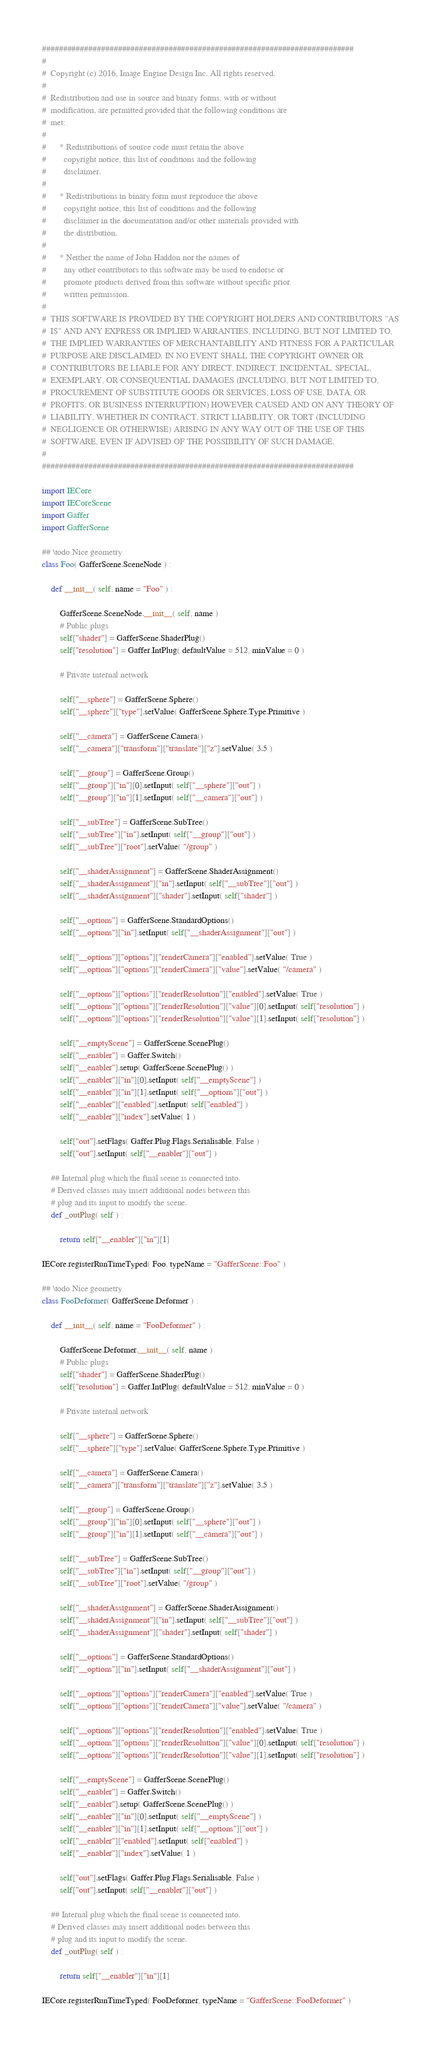<code> <loc_0><loc_0><loc_500><loc_500><_Python_>##########################################################################
#
#  Copyright (c) 2016, Image Engine Design Inc. All rights reserved.
#
#  Redistribution and use in source and binary forms, with or without
#  modification, are permitted provided that the following conditions are
#  met:
#
#      * Redistributions of source code must retain the above
#        copyright notice, this list of conditions and the following
#        disclaimer.
#
#      * Redistributions in binary form must reproduce the above
#        copyright notice, this list of conditions and the following
#        disclaimer in the documentation and/or other materials provided with
#        the distribution.
#
#      * Neither the name of John Haddon nor the names of
#        any other contributors to this software may be used to endorse or
#        promote products derived from this software without specific prior
#        written permission.
#
#  THIS SOFTWARE IS PROVIDED BY THE COPYRIGHT HOLDERS AND CONTRIBUTORS "AS
#  IS" AND ANY EXPRESS OR IMPLIED WARRANTIES, INCLUDING, BUT NOT LIMITED TO,
#  THE IMPLIED WARRANTIES OF MERCHANTABILITY AND FITNESS FOR A PARTICULAR
#  PURPOSE ARE DISCLAIMED. IN NO EVENT SHALL THE COPYRIGHT OWNER OR
#  CONTRIBUTORS BE LIABLE FOR ANY DIRECT, INDIRECT, INCIDENTAL, SPECIAL,
#  EXEMPLARY, OR CONSEQUENTIAL DAMAGES (INCLUDING, BUT NOT LIMITED TO,
#  PROCUREMENT OF SUBSTITUTE GOODS OR SERVICES; LOSS OF USE, DATA, OR
#  PROFITS; OR BUSINESS INTERRUPTION) HOWEVER CAUSED AND ON ANY THEORY OF
#  LIABILITY, WHETHER IN CONTRACT, STRICT LIABILITY, OR TORT (INCLUDING
#  NEGLIGENCE OR OTHERWISE) ARISING IN ANY WAY OUT OF THE USE OF THIS
#  SOFTWARE, EVEN IF ADVISED OF THE POSSIBILITY OF SUCH DAMAGE.
#
##########################################################################

import IECore
import IECoreScene
import Gaffer
import GafferScene

## \todo Nice geometry
class Foo( GafferScene.SceneNode ) :

	def __init__( self, name = "Foo" ) :

		GafferScene.SceneNode.__init__( self, name )
		# Public plugs
		self["shader"] = GafferScene.ShaderPlug()
		self["resolution"] = Gaffer.IntPlug( defaultValue = 512, minValue = 0 )

		# Private internal network

		self["__sphere"] = GafferScene.Sphere()
		self["__sphere"]["type"].setValue( GafferScene.Sphere.Type.Primitive )

		self["__camera"] = GafferScene.Camera()
		self["__camera"]["transform"]["translate"]["z"].setValue( 3.5 )

		self["__group"] = GafferScene.Group()
		self["__group"]["in"][0].setInput( self["__sphere"]["out"] )
		self["__group"]["in"][1].setInput( self["__camera"]["out"] )

		self["__subTree"] = GafferScene.SubTree()
		self["__subTree"]["in"].setInput( self["__group"]["out"] )
		self["__subTree"]["root"].setValue( "/group" )

		self["__shaderAssignment"] = GafferScene.ShaderAssignment()
		self["__shaderAssignment"]["in"].setInput( self["__subTree"]["out"] )
		self["__shaderAssignment"]["shader"].setInput( self["shader"] )

		self["__options"] = GafferScene.StandardOptions()
		self["__options"]["in"].setInput( self["__shaderAssignment"]["out"] )

		self["__options"]["options"]["renderCamera"]["enabled"].setValue( True )
		self["__options"]["options"]["renderCamera"]["value"].setValue( "/camera" )

		self["__options"]["options"]["renderResolution"]["enabled"].setValue( True )
		self["__options"]["options"]["renderResolution"]["value"][0].setInput( self["resolution"] )
		self["__options"]["options"]["renderResolution"]["value"][1].setInput( self["resolution"] )

		self["__emptyScene"] = GafferScene.ScenePlug()
		self["__enabler"] = Gaffer.Switch()
		self["__enabler"].setup( GafferScene.ScenePlug() )
		self["__enabler"]["in"][0].setInput( self["__emptyScene"] )
		self["__enabler"]["in"][1].setInput( self["__options"]["out"] )
		self["__enabler"]["enabled"].setInput( self["enabled"] )
		self["__enabler"]["index"].setValue( 1 )

		self["out"].setFlags( Gaffer.Plug.Flags.Serialisable, False )
		self["out"].setInput( self["__enabler"]["out"] )

	## Internal plug which the final scene is connected into.
	# Derived classes may insert additional nodes between this
	# plug and its input to modify the scene.
	def _outPlug( self ) :

		return self["__enabler"]["in"][1]

IECore.registerRunTimeTyped( Foo, typeName = "GafferScene::Foo" )

## \todo Nice geometry
class FooDeformer( GafferScene.Deformer ) :

	def __init__( self, name = "FooDeformer" ) :

		GafferScene.Deformer.__init__( self, name )
		# Public plugs
		self["shader"] = GafferScene.ShaderPlug()
		self["resolution"] = Gaffer.IntPlug( defaultValue = 512, minValue = 0 )

		# Private internal network

		self["__sphere"] = GafferScene.Sphere()
		self["__sphere"]["type"].setValue( GafferScene.Sphere.Type.Primitive )

		self["__camera"] = GafferScene.Camera()
		self["__camera"]["transform"]["translate"]["z"].setValue( 3.5 )

		self["__group"] = GafferScene.Group()
		self["__group"]["in"][0].setInput( self["__sphere"]["out"] )
		self["__group"]["in"][1].setInput( self["__camera"]["out"] )

		self["__subTree"] = GafferScene.SubTree()
		self["__subTree"]["in"].setInput( self["__group"]["out"] )
		self["__subTree"]["root"].setValue( "/group" )

		self["__shaderAssignment"] = GafferScene.ShaderAssignment()
		self["__shaderAssignment"]["in"].setInput( self["__subTree"]["out"] )
		self["__shaderAssignment"]["shader"].setInput( self["shader"] )

		self["__options"] = GafferScene.StandardOptions()
		self["__options"]["in"].setInput( self["__shaderAssignment"]["out"] )

		self["__options"]["options"]["renderCamera"]["enabled"].setValue( True )
		self["__options"]["options"]["renderCamera"]["value"].setValue( "/camera" )

		self["__options"]["options"]["renderResolution"]["enabled"].setValue( True )
		self["__options"]["options"]["renderResolution"]["value"][0].setInput( self["resolution"] )
		self["__options"]["options"]["renderResolution"]["value"][1].setInput( self["resolution"] )

		self["__emptyScene"] = GafferScene.ScenePlug()
		self["__enabler"] = Gaffer.Switch()
		self["__enabler"].setup( GafferScene.ScenePlug() )
		self["__enabler"]["in"][0].setInput( self["__emptyScene"] )
		self["__enabler"]["in"][1].setInput( self["__options"]["out"] )
		self["__enabler"]["enabled"].setInput( self["enabled"] )
		self["__enabler"]["index"].setValue( 1 )

		self["out"].setFlags( Gaffer.Plug.Flags.Serialisable, False )
		self["out"].setInput( self["__enabler"]["out"] )

	## Internal plug which the final scene is connected into.
	# Derived classes may insert additional nodes between this
	# plug and its input to modify the scene.
	def _outPlug( self ) :

		return self["__enabler"]["in"][1]

IECore.registerRunTimeTyped( FooDeformer, typeName = "GafferScene::FooDeformer" )
</code> 